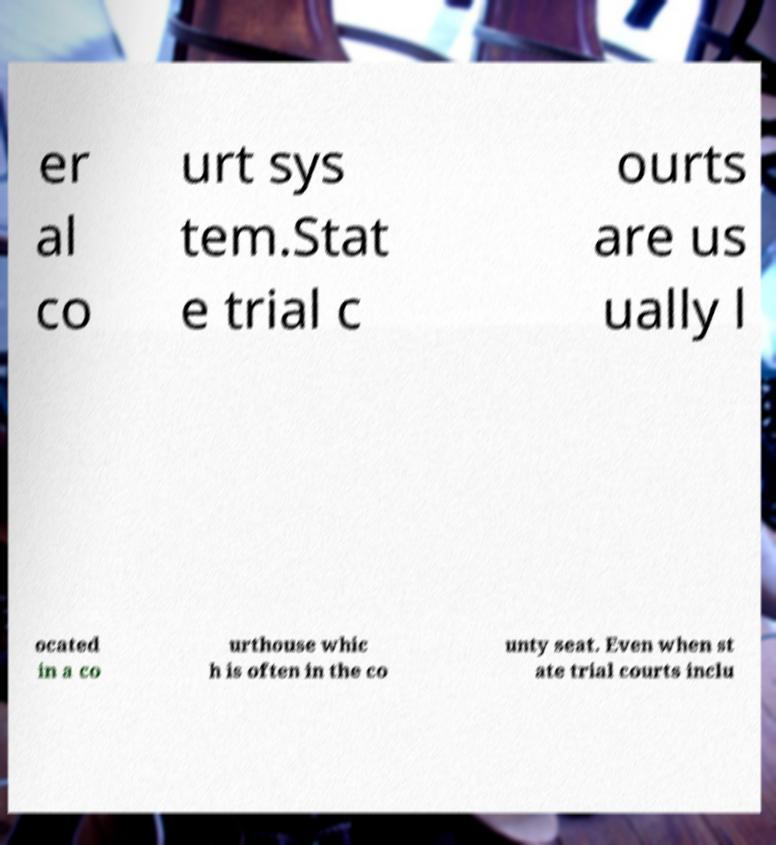Can you read and provide the text displayed in the image?This photo seems to have some interesting text. Can you extract and type it out for me? er al co urt sys tem.Stat e trial c ourts are us ually l ocated in a co urthouse whic h is often in the co unty seat. Even when st ate trial courts inclu 